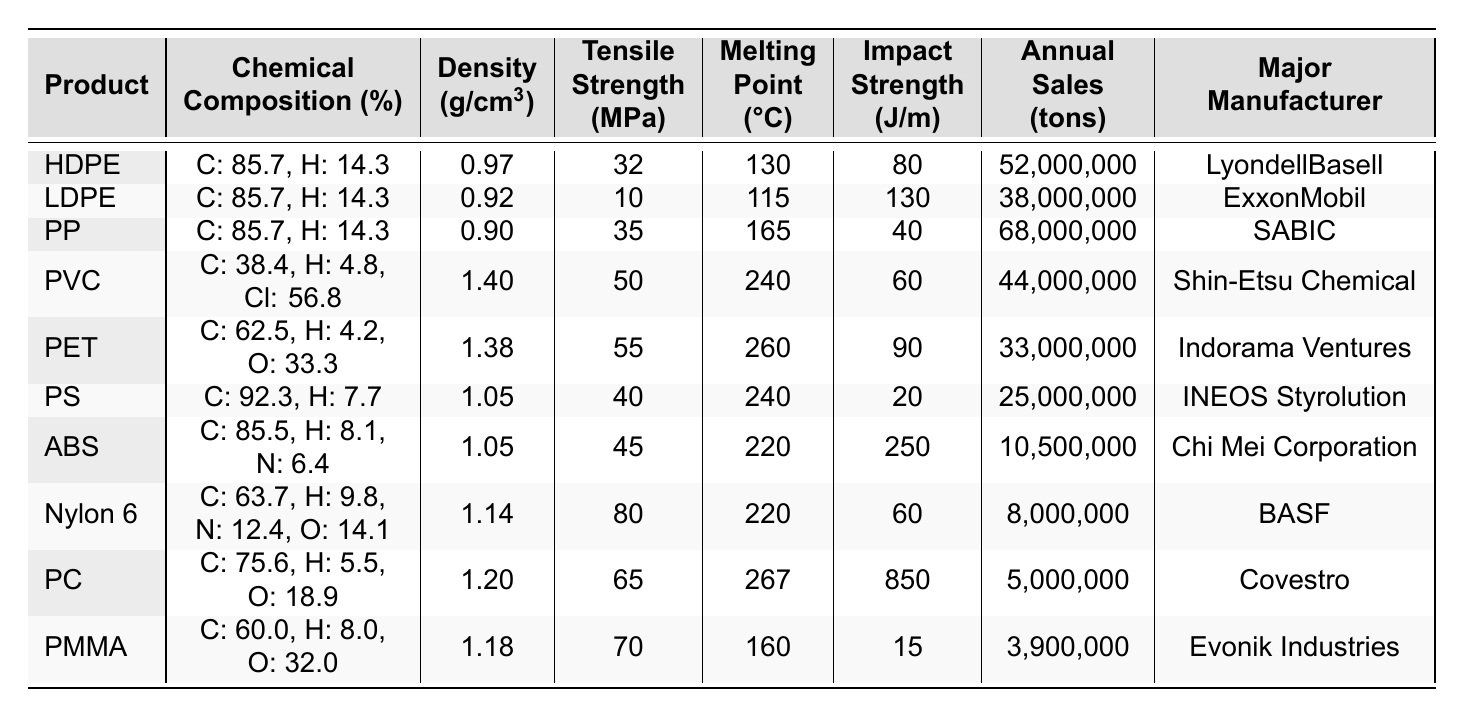What is the tensile strength of Polypropylene (PP)? The table lists the tensile strength for Polypropylene (PP) in the respective column, which is 35 MPa.
Answer: 35 MPa Which plastic has the highest impact strength? By comparing the impact strength values in the table, Polycarbonate (PC) has the highest value at 850 J/m.
Answer: Polycarbonate (PC) What is the major manufacturer of Polyvinyl Chloride (PVC)? The table shows that the major manufacturer of Polyvinyl Chloride (PVC) is Shin-Etsu Chemical.
Answer: Shin-Etsu Chemical How many tons of Acrylonitrile Butadiene Styrene (ABS) are sold annually? According to the table, Acrylonitrile Butadiene Styrene (ABS) has annual sales of 10,500,000 tons.
Answer: 10,500,000 tons What is the average density of the plastics listed? First, sum all the densities: (0.97 + 0.92 + 0.90 + 1.40 + 1.38 + 1.05 + 1.05 + 1.14 + 1.20 + 1.18) = 12.09. There are 10 products, so the average density is 12.09 / 10 = 1.209 g/cm³.
Answer: 1.209 g/cm³ Does Low-Density Polyethylene (LDPE) have a higher tensile strength than High-Density Polyethylene (HDPE)? The table lists LDPE's tensile strength at 10 MPa and HDPE's tensile strength at 32 MPa, so LDPE does not have a higher tensile strength.
Answer: No Which plastic has the lowest annual sales, and what is the value? By reviewing the annual sales figures in the table, Polymethyl Methacrylate (PMMA) has the lowest sales of 3,900,000 tons.
Answer: Polymethyl Methacrylate (PMMA), 3,900,000 tons What is the difference in melting points between Polyethylene Terephthalate (PET) and Polystyrene (PS)? The melting point of PET is 260 °C, and for PS, it is 240 °C. The difference is 260 - 240 = 20 °C.
Answer: 20 °C Which plastic has the highest percentage of carbon in its chemical composition? Examining the chemical compositions, Polystyrene (PS) has the highest carbon percentage at 92.3%.
Answer: Polystyrene (PS), 92.3% If we were to rank the plastics based on their tensile strength, which would be the top three? The tensile strengths in order are: Polyamide (Nylon 6) at 80 MPa, Polycarbonate (PC) at 65 MPa, and Polyethylene Terephthalate (PET) at 55 MPa. The top three are: Nylon 6, PC, and PET.
Answer: Nylon 6, PC, PET 